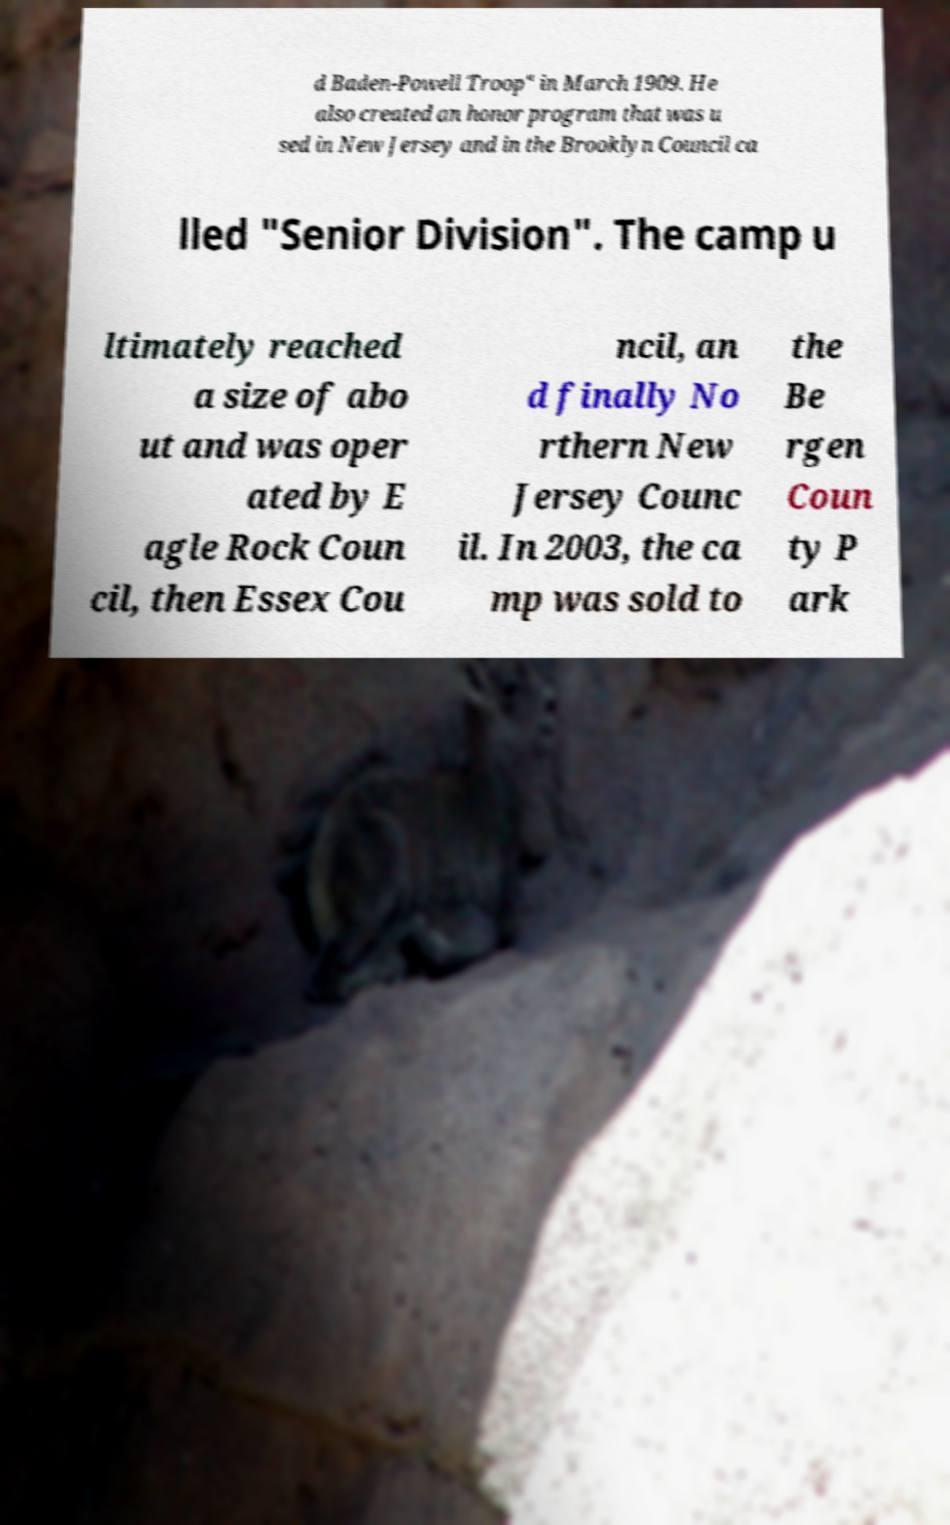Could you extract and type out the text from this image? d Baden-Powell Troop" in March 1909. He also created an honor program that was u sed in New Jersey and in the Brooklyn Council ca lled "Senior Division". The camp u ltimately reached a size of abo ut and was oper ated by E agle Rock Coun cil, then Essex Cou ncil, an d finally No rthern New Jersey Counc il. In 2003, the ca mp was sold to the Be rgen Coun ty P ark 